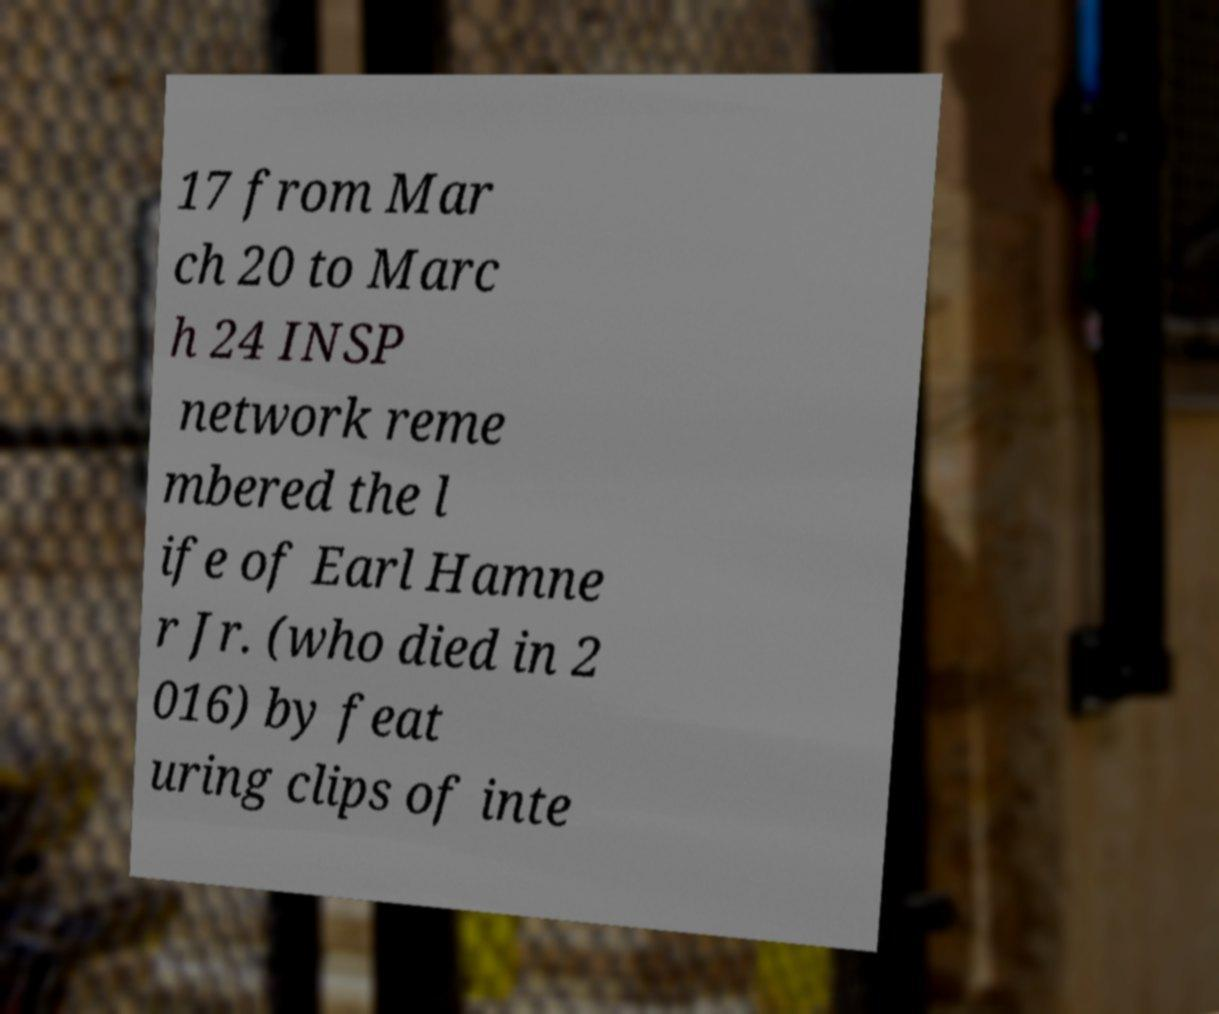There's text embedded in this image that I need extracted. Can you transcribe it verbatim? 17 from Mar ch 20 to Marc h 24 INSP network reme mbered the l ife of Earl Hamne r Jr. (who died in 2 016) by feat uring clips of inte 